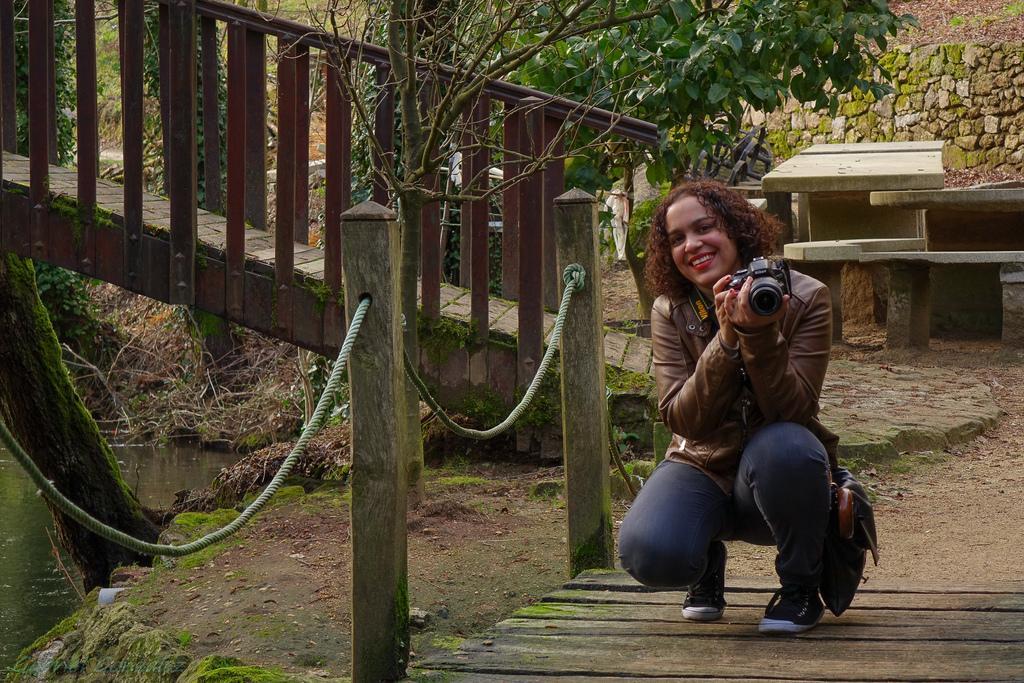Could you give a brief overview of what you see in this image? In this image in the center there is a woman squatting holding a camera in her hand and smiling. On the left side of the woman there is a staircase and there is a rope fence. In the background there are trees and there is a wall. 